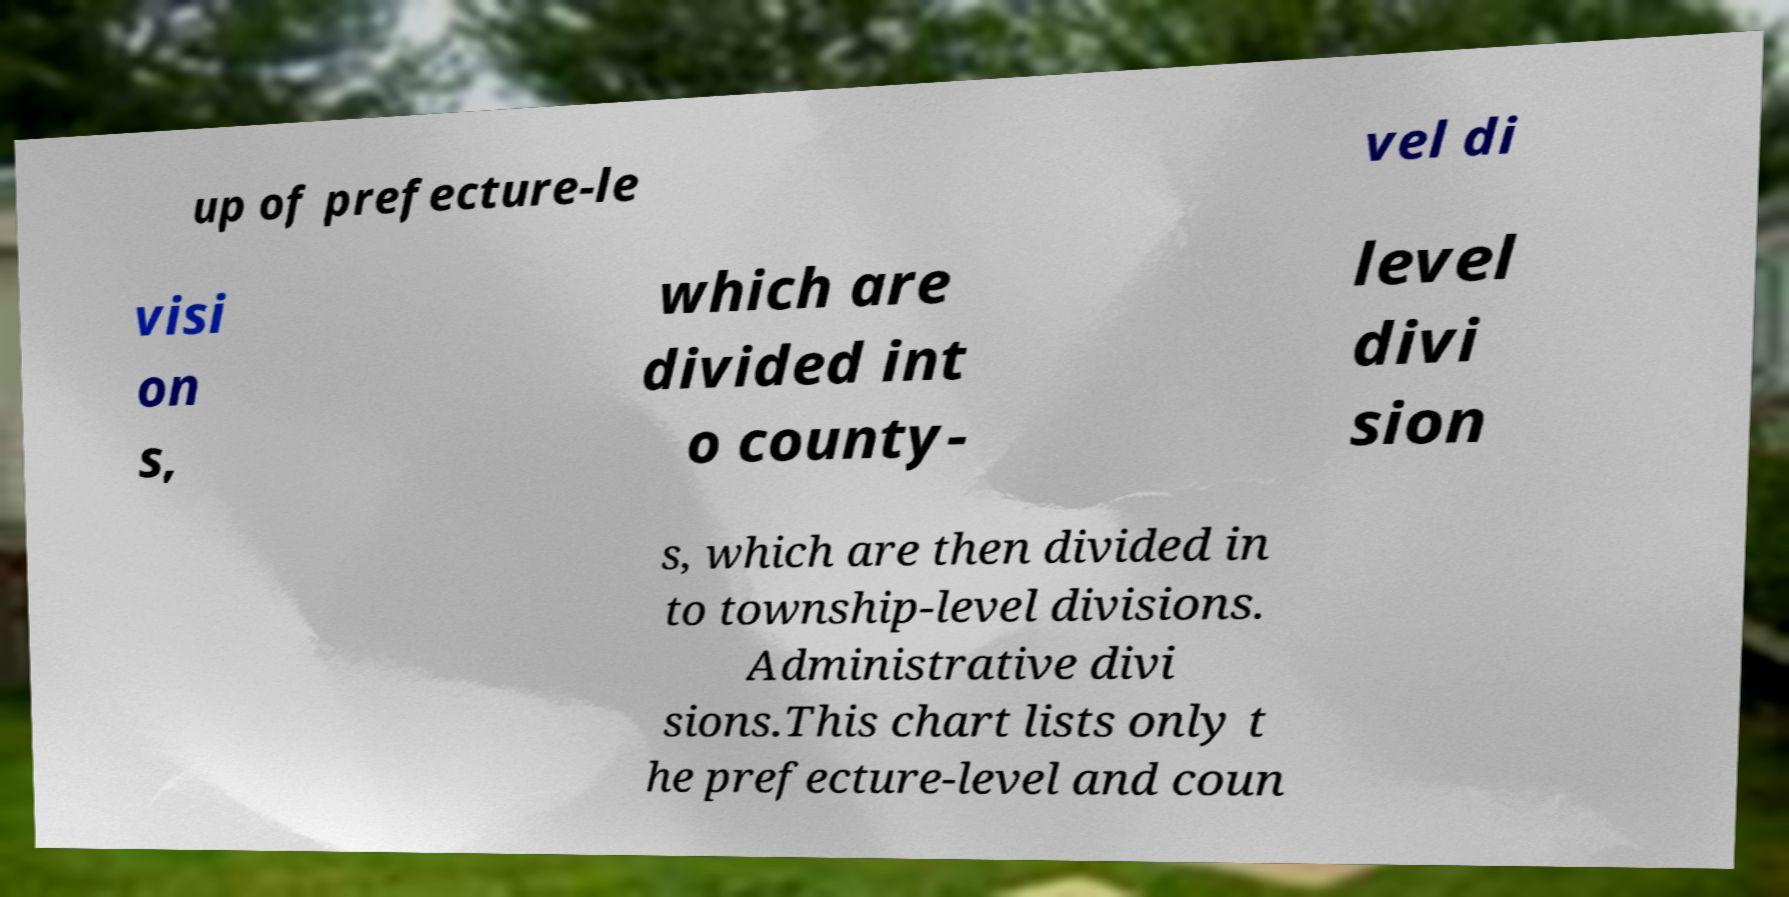Please identify and transcribe the text found in this image. up of prefecture-le vel di visi on s, which are divided int o county- level divi sion s, which are then divided in to township-level divisions. Administrative divi sions.This chart lists only t he prefecture-level and coun 